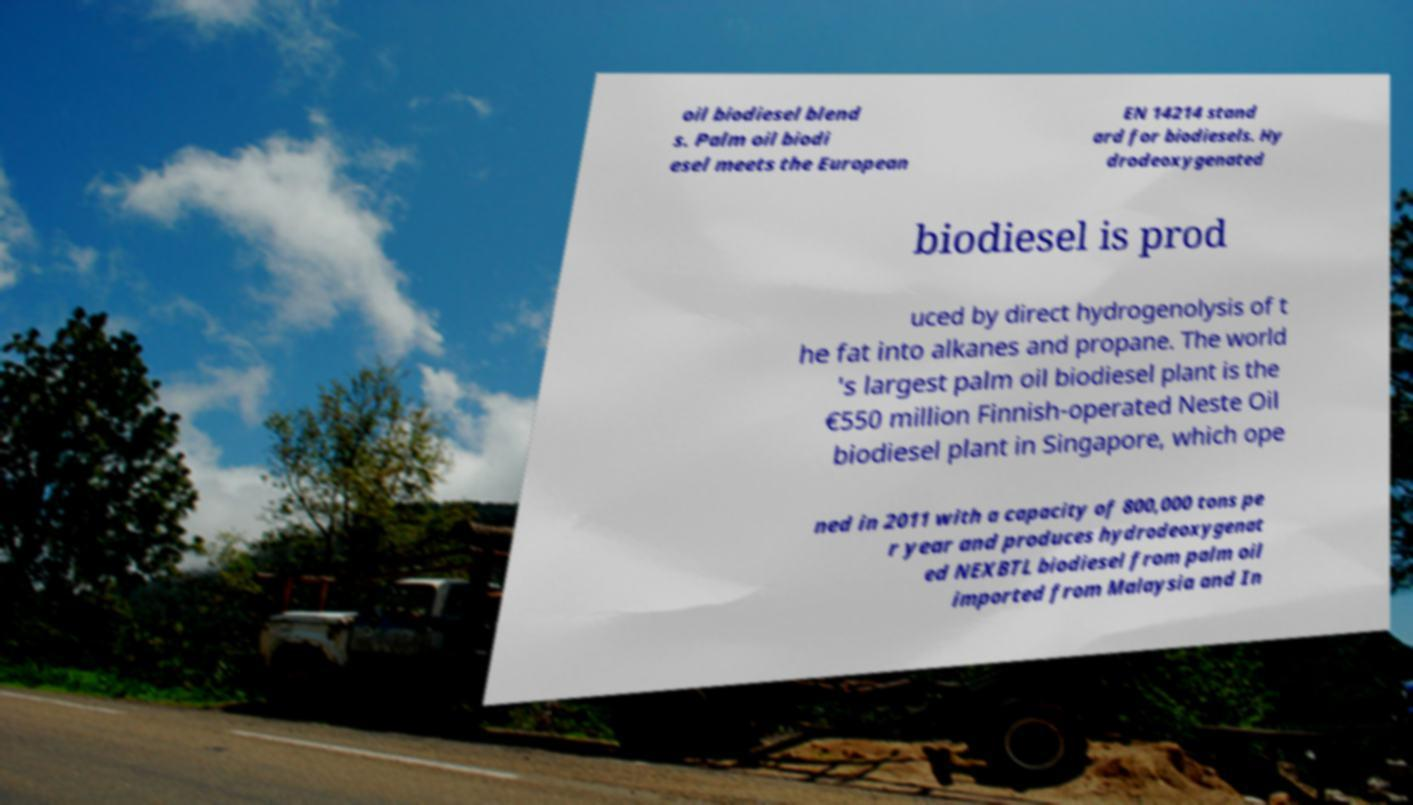I need the written content from this picture converted into text. Can you do that? oil biodiesel blend s. Palm oil biodi esel meets the European EN 14214 stand ard for biodiesels. Hy drodeoxygenated biodiesel is prod uced by direct hydrogenolysis of t he fat into alkanes and propane. The world 's largest palm oil biodiesel plant is the €550 million Finnish-operated Neste Oil biodiesel plant in Singapore, which ope ned in 2011 with a capacity of 800,000 tons pe r year and produces hydrodeoxygenat ed NEXBTL biodiesel from palm oil imported from Malaysia and In 